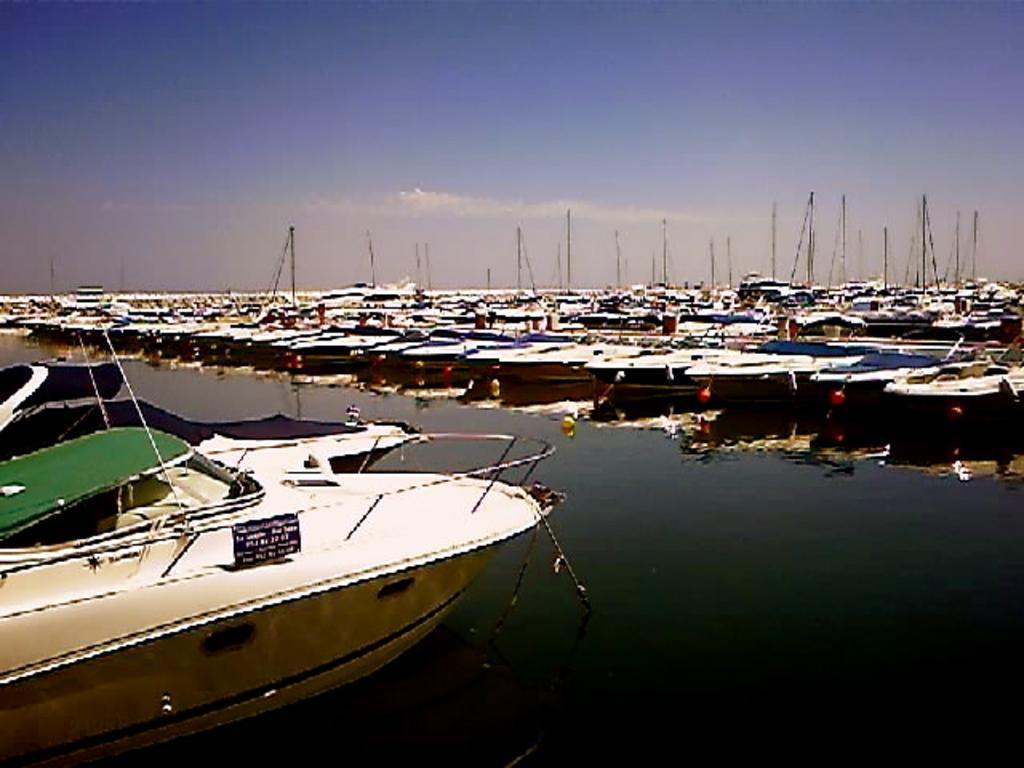How would you summarize this image in a sentence or two? In this image we can see a boat in the water body. We can also see a group of boats with poles which are placed aside and the sky which looks cloudy. 